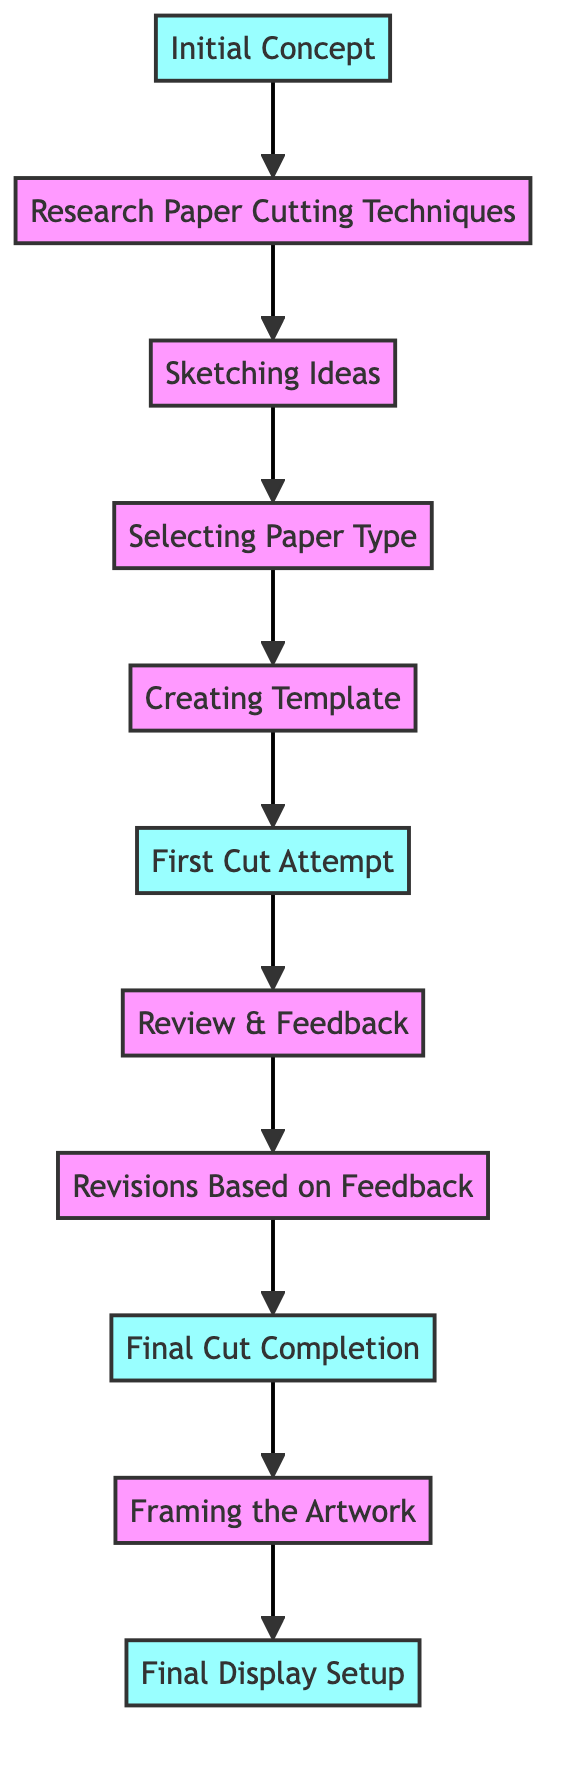What is the first step in the paper cutting project? The first step is represented by the node labeled "Initial Concept". It is the starting point of the directed graph, indicating where the project begins.
Answer: Initial Concept How many nodes are in the diagram? By counting each unique labeled node in the diagram, there are a total of 11 nodes representing different stages of the project.
Answer: 11 What stage comes after selecting paper type? Following the node labeled "Selecting Paper Type", the next step indicated in the graph is represented by the node labeled "Creating Template".
Answer: Creating Template Which milestone involves feedback? The node labeled "Review & Feedback" is where feedback on the initial cut is gathered, making it a significant milestone in the process.
Answer: Review & Feedback What is the last step in the paper cutting process? The final step in the development of this project is represented by the node labeled "Final Display Setup", where the completed artwork is prepared for presentation.
Answer: Final Display Setup What is the relationship between "First Cut Attempt" and "Final Cut Completion"? The node "First Cut Attempt" leads to the next stage "Review & Feedback", which, after revisions, ultimately leads to "Final Cut Completion", indicating a direct progression in the flow of the project.
Answer: Review & Feedback How many milestones are present in the diagram? The diagram has 5 milestones, which are the steps highlighted as crucial points in the project development.
Answer: 5 What step comes directly after "Revisions Based on Feedback"? The next step that directly follows "Revisions Based on Feedback" is "Final Cut Completion", indicating the project's progression after making adjustments based on earlier reviews.
Answer: Final Cut Completion 